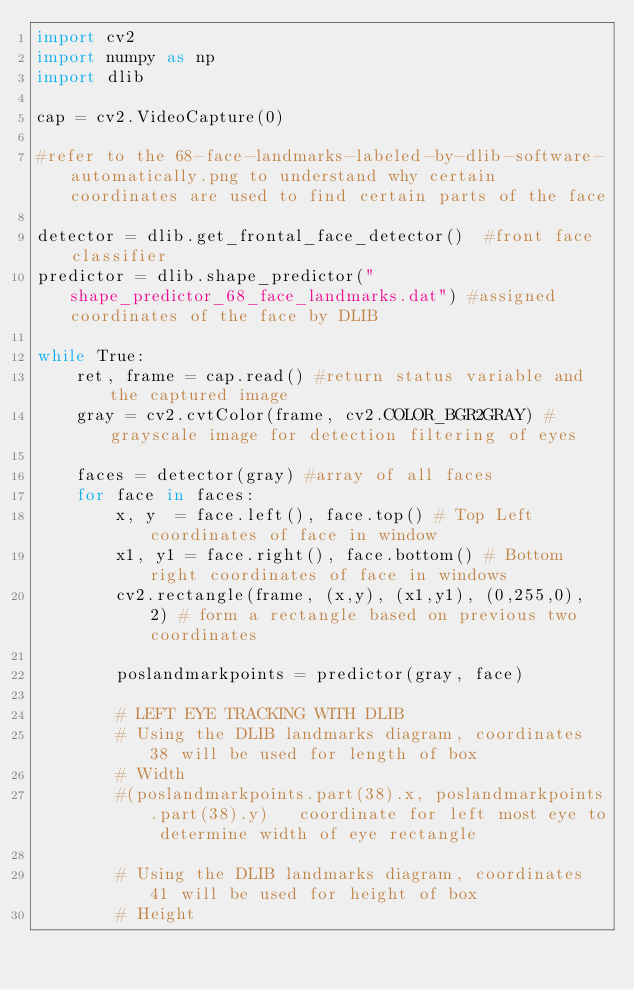<code> <loc_0><loc_0><loc_500><loc_500><_Python_>import cv2
import numpy as np
import dlib

cap = cv2.VideoCapture(0)

#refer to the 68-face-landmarks-labeled-by-dlib-software-automatically.png to understand why certain coordinates are used to find certain parts of the face

detector = dlib.get_frontal_face_detector()  #front face classifier
predictor = dlib.shape_predictor("shape_predictor_68_face_landmarks.dat") #assigned coordinates of the face by DLIB

while True:
    ret, frame = cap.read() #return status variable and the captured image
    gray = cv2.cvtColor(frame, cv2.COLOR_BGR2GRAY) #grayscale image for detection filtering of eyes

    faces = detector(gray) #array of all faces
    for face in faces:
        x, y  = face.left(), face.top() # Top Left coordinates of face in window
        x1, y1 = face.right(), face.bottom() # Bottom right coordinates of face in windows
        cv2.rectangle(frame, (x,y), (x1,y1), (0,255,0), 2) # form a rectangle based on previous two coordinates

        poslandmarkpoints = predictor(gray, face)

        # LEFT EYE TRACKING WITH DLIB
        # Using the DLIB landmarks diagram, coordinates 38 will be used for length of box
        # Width
        #(poslandmarkpoints.part(38).x, poslandmarkpoints.part(38).y)   coordinate for left most eye to determine width of eye rectangle
        
        # Using the DLIB landmarks diagram, coordinates 41 will be used for height of box
        # Height</code> 